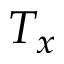<formula> <loc_0><loc_0><loc_500><loc_500>T _ { x }</formula> 